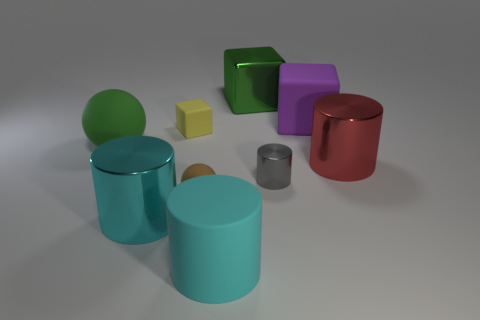How many cyan metal cylinders are on the left side of the tiny rubber thing that is behind the large red metallic thing that is in front of the large green metal thing?
Make the answer very short. 1. There is a small metal cylinder; does it have the same color as the tiny rubber object that is in front of the small matte block?
Give a very brief answer. No. The cube that is made of the same material as the small gray object is what size?
Offer a terse response. Large. Are there more small cubes in front of the small yellow thing than red matte balls?
Your response must be concise. No. The small thing behind the matte object that is to the left of the small yellow matte block that is behind the tiny metal object is made of what material?
Your answer should be compact. Rubber. Is the material of the tiny gray cylinder the same as the block in front of the large purple block?
Provide a short and direct response. No. There is a big red thing that is the same shape as the tiny metal thing; what material is it?
Your answer should be compact. Metal. Is there any other thing that has the same material as the tiny yellow cube?
Provide a short and direct response. Yes. Is the number of blocks on the right side of the large red cylinder greater than the number of brown rubber balls that are behind the tiny gray thing?
Your answer should be compact. No. The cyan thing that is made of the same material as the purple cube is what shape?
Your answer should be very brief. Cylinder. 